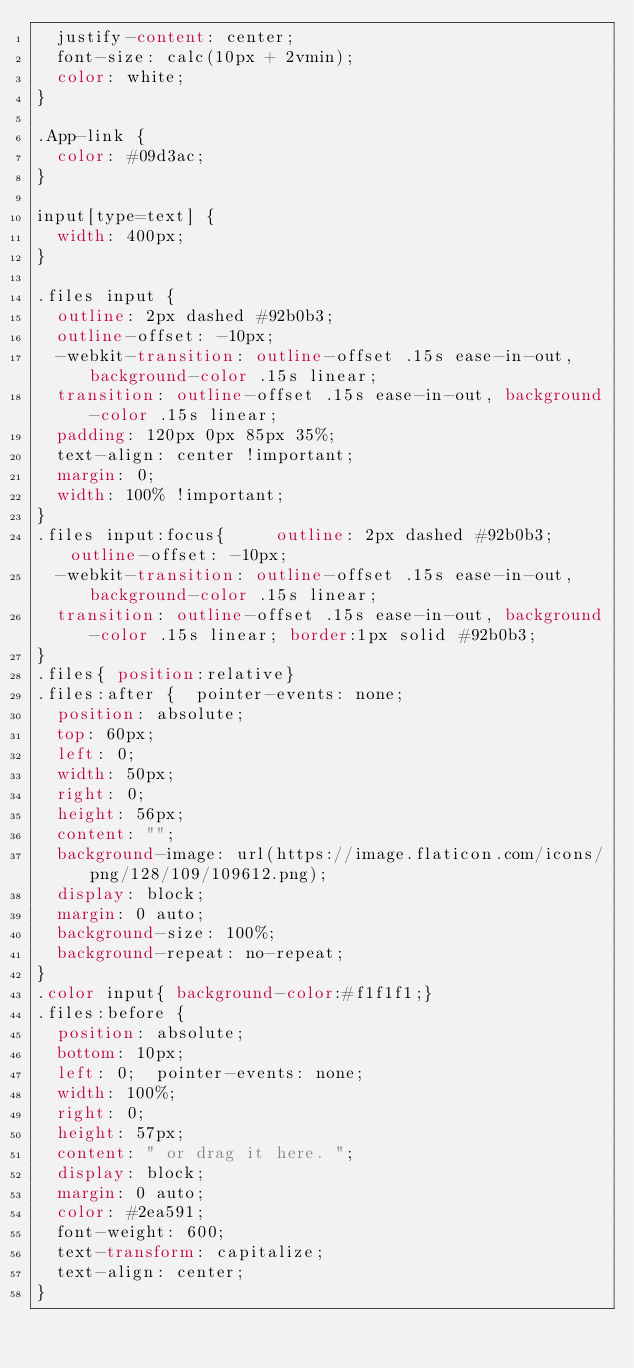Convert code to text. <code><loc_0><loc_0><loc_500><loc_500><_CSS_>  justify-content: center;
  font-size: calc(10px + 2vmin);
  color: white;
}

.App-link {
  color: #09d3ac;
}

input[type=text] {
  width: 400px;
}

.files input {
  outline: 2px dashed #92b0b3;
  outline-offset: -10px;
  -webkit-transition: outline-offset .15s ease-in-out, background-color .15s linear;
  transition: outline-offset .15s ease-in-out, background-color .15s linear;
  padding: 120px 0px 85px 35%;
  text-align: center !important;
  margin: 0;
  width: 100% !important;
}
.files input:focus{     outline: 2px dashed #92b0b3;  outline-offset: -10px;
  -webkit-transition: outline-offset .15s ease-in-out, background-color .15s linear;
  transition: outline-offset .15s ease-in-out, background-color .15s linear; border:1px solid #92b0b3;
}
.files{ position:relative}
.files:after {  pointer-events: none;
  position: absolute;
  top: 60px;
  left: 0;
  width: 50px;
  right: 0;
  height: 56px;
  content: "";
  background-image: url(https://image.flaticon.com/icons/png/128/109/109612.png);
  display: block;
  margin: 0 auto;
  background-size: 100%;
  background-repeat: no-repeat;
}
.color input{ background-color:#f1f1f1;}
.files:before {
  position: absolute;
  bottom: 10px;
  left: 0;  pointer-events: none;
  width: 100%;
  right: 0;
  height: 57px;
  content: " or drag it here. ";
  display: block;
  margin: 0 auto;
  color: #2ea591;
  font-weight: 600;
  text-transform: capitalize;
  text-align: center;
}</code> 